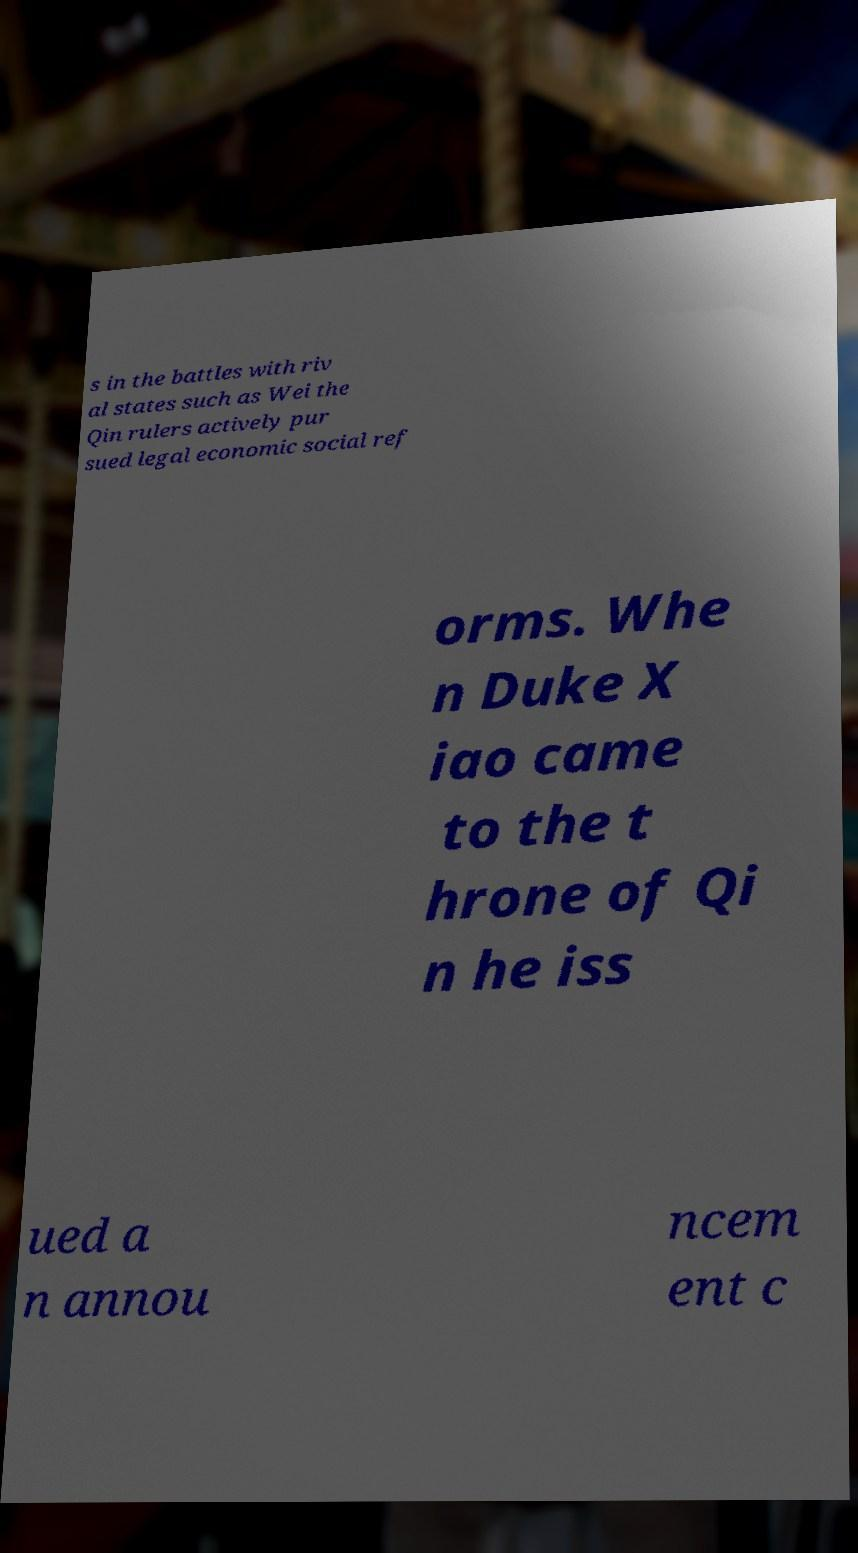Could you assist in decoding the text presented in this image and type it out clearly? s in the battles with riv al states such as Wei the Qin rulers actively pur sued legal economic social ref orms. Whe n Duke X iao came to the t hrone of Qi n he iss ued a n annou ncem ent c 